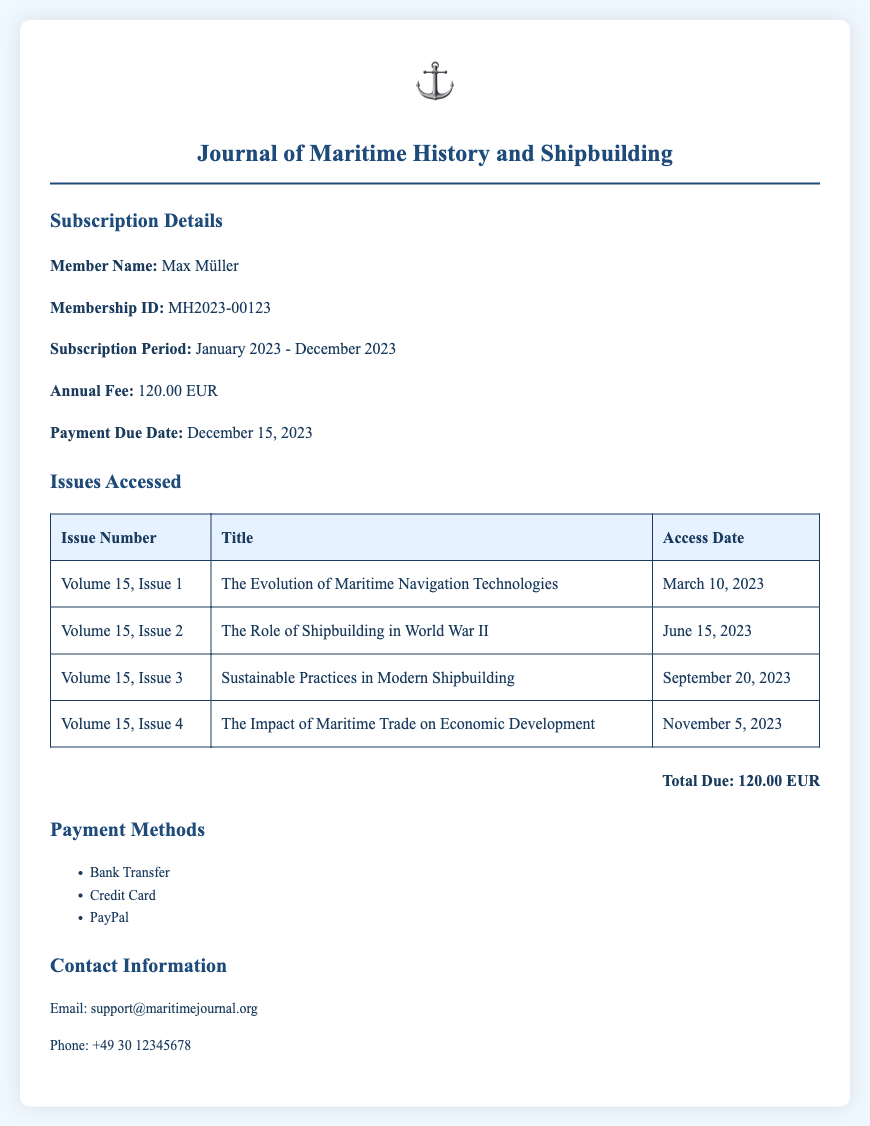What is the member name? The member name is indicated in the subscription details section of the document.
Answer: Max Müller What is the membership ID? The membership ID is provided in the subscription details, identifying the member uniquely.
Answer: MH2023-00123 What is the subscription period? The subscription period specifies the duration for which the membership is valid.
Answer: January 2023 - December 2023 What is the total amount due? The total amount due is summarized at the end of the document, representing the annual fee for the subscription.
Answer: 120.00 EUR When is the payment due date? The payment due date is mentioned in the subscription details, indicating when the payment must be made.
Answer: December 15, 2023 Which issue was accessed on March 10, 2023? Looking at the issues accessed table, the title corresponding to that date is listed.
Answer: The Evolution of Maritime Navigation Technologies How many issues have been accessed? By counting the rows in the issues accessed section, one can determine the total number of issues accessed.
Answer: 4 What are the payment methods available? The payment methods are outlined in a specific section of the document, listing the options for making payments.
Answer: Bank Transfer, Credit Card, PayPal What is the title of the second issue? The title of issues can be found in the issues accessed table, detailing the content of each issue.
Answer: The Role of Shipbuilding in World War II 